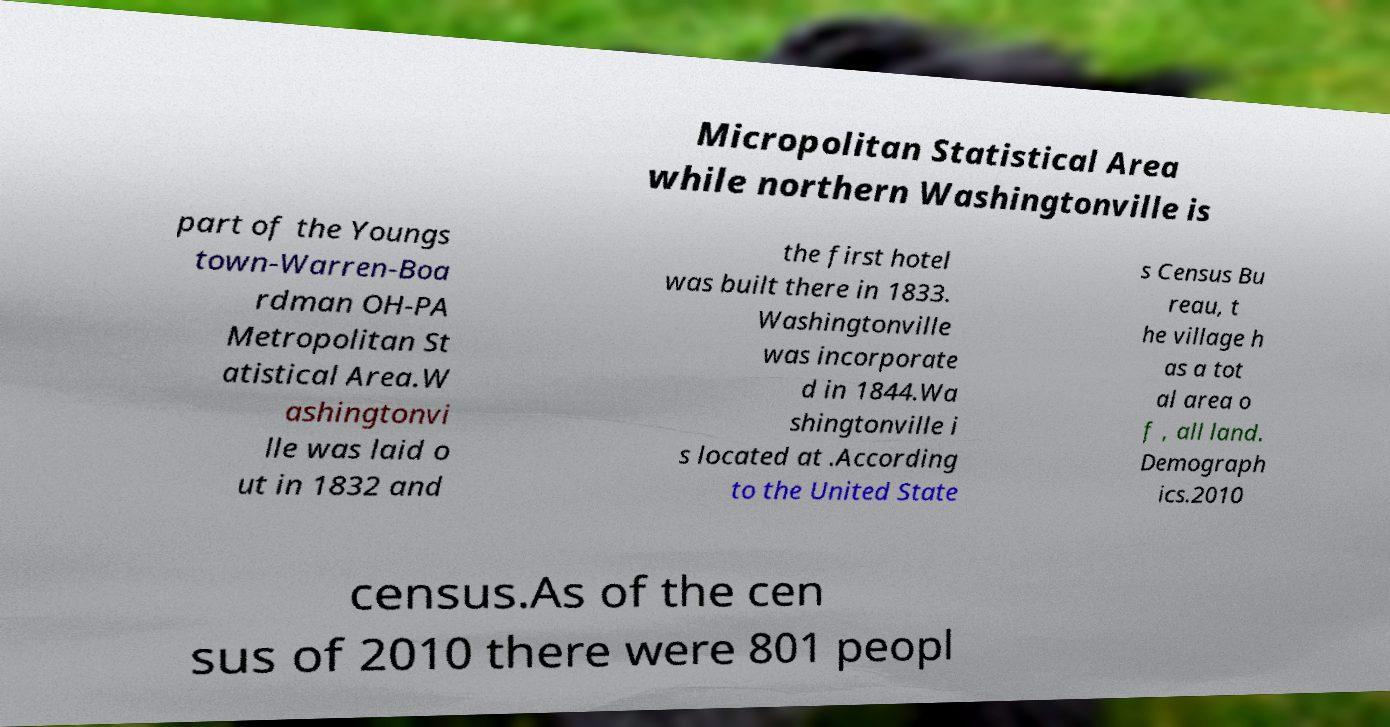Could you extract and type out the text from this image? Micropolitan Statistical Area while northern Washingtonville is part of the Youngs town-Warren-Boa rdman OH-PA Metropolitan St atistical Area.W ashingtonvi lle was laid o ut in 1832 and the first hotel was built there in 1833. Washingtonville was incorporate d in 1844.Wa shingtonville i s located at .According to the United State s Census Bu reau, t he village h as a tot al area o f , all land. Demograph ics.2010 census.As of the cen sus of 2010 there were 801 peopl 